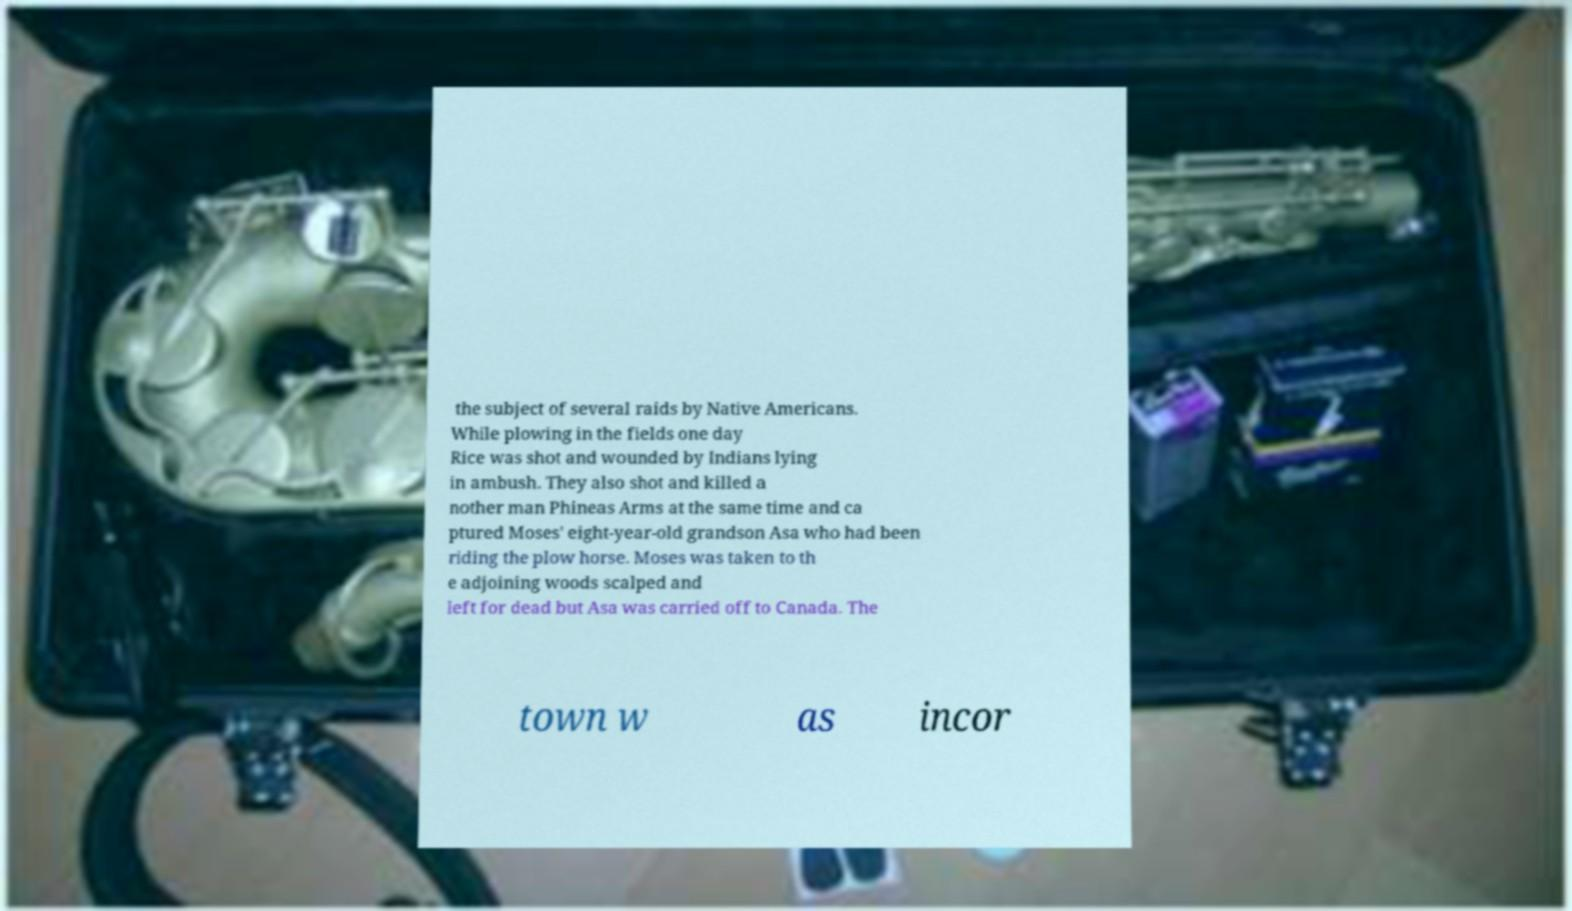There's text embedded in this image that I need extracted. Can you transcribe it verbatim? the subject of several raids by Native Americans. While plowing in the fields one day Rice was shot and wounded by Indians lying in ambush. They also shot and killed a nother man Phineas Arms at the same time and ca ptured Moses' eight-year-old grandson Asa who had been riding the plow horse. Moses was taken to th e adjoining woods scalped and left for dead but Asa was carried off to Canada. The town w as incor 